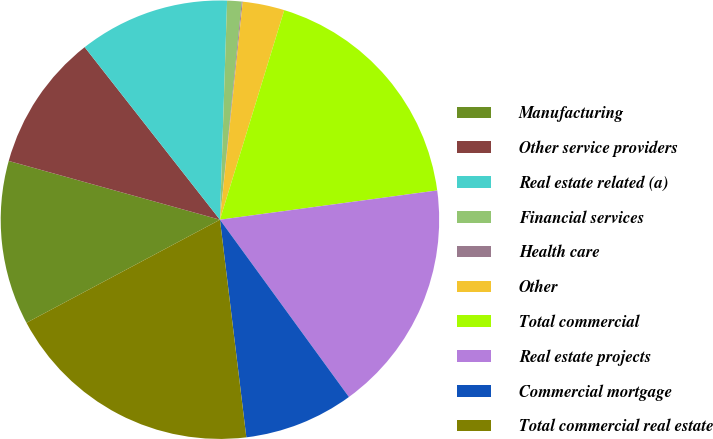Convert chart. <chart><loc_0><loc_0><loc_500><loc_500><pie_chart><fcel>Manufacturing<fcel>Other service providers<fcel>Real estate related (a)<fcel>Financial services<fcel>Health care<fcel>Other<fcel>Total commercial<fcel>Real estate projects<fcel>Commercial mortgage<fcel>Total commercial real estate<nl><fcel>12.11%<fcel>10.1%<fcel>11.1%<fcel>1.07%<fcel>0.07%<fcel>3.08%<fcel>18.13%<fcel>17.12%<fcel>8.09%<fcel>19.13%<nl></chart> 